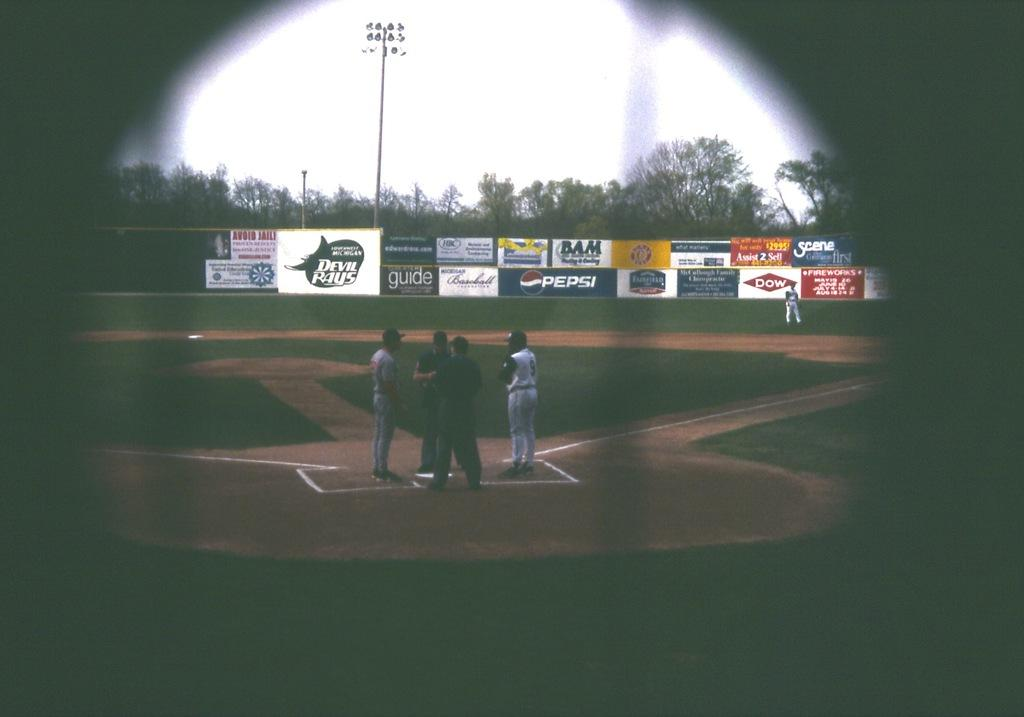What is the main subject of the image? The main subject of the image is a playground. Are there any people present in the image? Yes, there are persons standing in the playground. What can be seen in the background of the image? There are trees and sky visible in the image. What type of structure is present in the image? There is a pole in the image. What else can be seen in the playground? There are boards in the image. What type of bun is being served at the news conference in the image? A: There is no news conference or bun present in the image; it features a playground with people and various structures. 